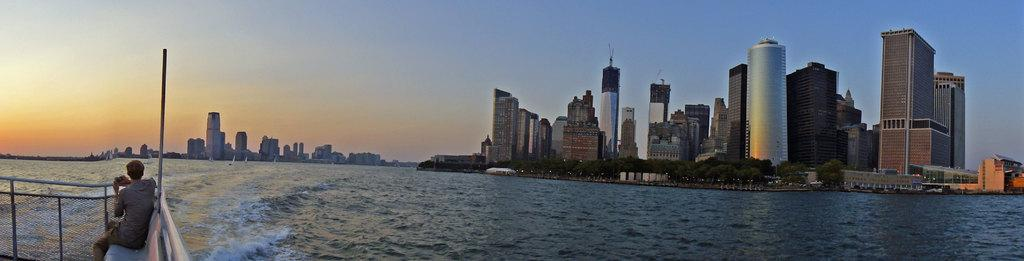Who or what is in the image? There is a person in the image. What is the person doing in the image? The person is sitting on a boat. What is in front of the person? There is water in front of the person. What can be seen in the background of the image? There are buildings and trees in the background of the image. How many horses can be seen in the image? There are no horses present in the image. What type of haircut does the person have in the image? The provided facts do not mention the person's haircut, so it cannot be determined from the image. 